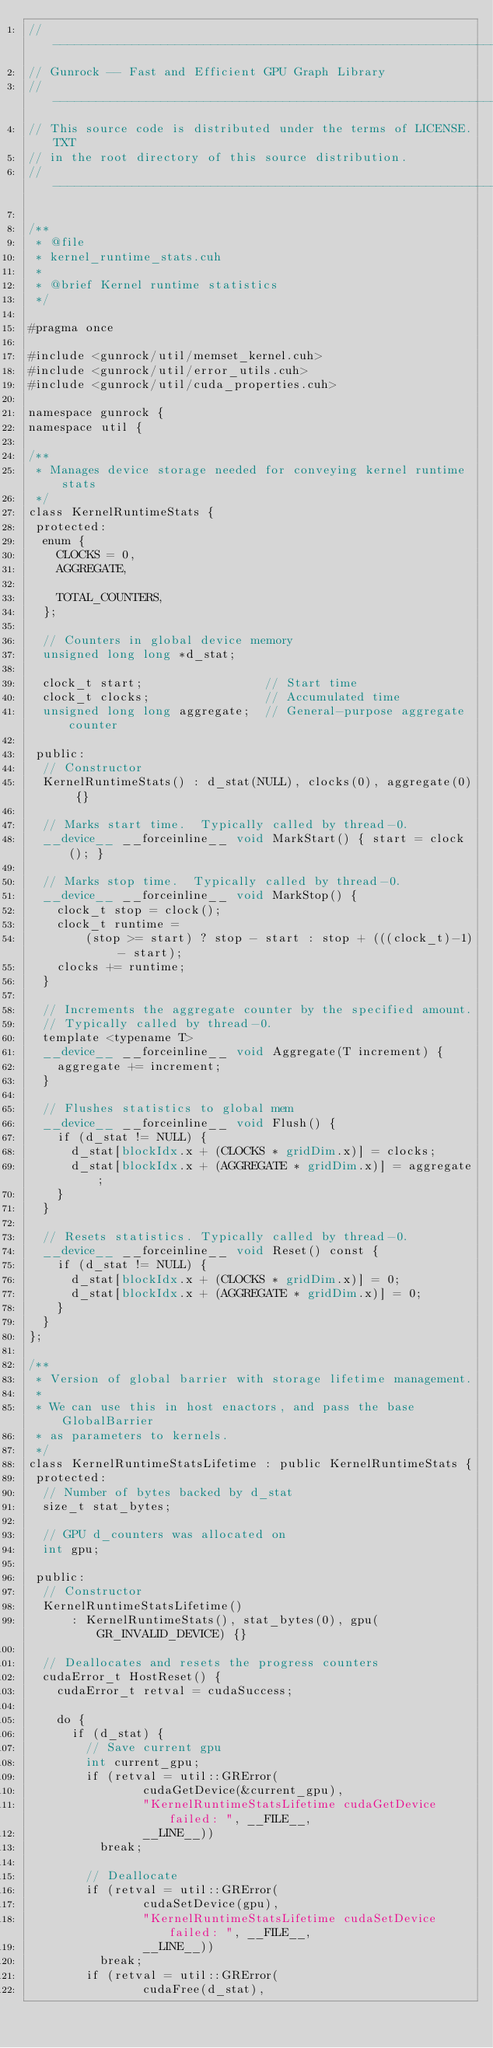Convert code to text. <code><loc_0><loc_0><loc_500><loc_500><_Cuda_>// ----------------------------------------------------------------
// Gunrock -- Fast and Efficient GPU Graph Library
// ----------------------------------------------------------------
// This source code is distributed under the terms of LICENSE.TXT
// in the root directory of this source distribution.
// ----------------------------------------------------------------

/**
 * @file
 * kernel_runtime_stats.cuh
 *
 * @brief Kernel runtime statistics
 */

#pragma once

#include <gunrock/util/memset_kernel.cuh>
#include <gunrock/util/error_utils.cuh>
#include <gunrock/util/cuda_properties.cuh>

namespace gunrock {
namespace util {

/**
 * Manages device storage needed for conveying kernel runtime stats
 */
class KernelRuntimeStats {
 protected:
  enum {
    CLOCKS = 0,
    AGGREGATE,

    TOTAL_COUNTERS,
  };

  // Counters in global device memory
  unsigned long long *d_stat;

  clock_t start;                 // Start time
  clock_t clocks;                // Accumulated time
  unsigned long long aggregate;  // General-purpose aggregate counter

 public:
  // Constructor
  KernelRuntimeStats() : d_stat(NULL), clocks(0), aggregate(0) {}

  // Marks start time.  Typically called by thread-0.
  __device__ __forceinline__ void MarkStart() { start = clock(); }

  // Marks stop time.  Typically called by thread-0.
  __device__ __forceinline__ void MarkStop() {
    clock_t stop = clock();
    clock_t runtime =
        (stop >= start) ? stop - start : stop + (((clock_t)-1) - start);
    clocks += runtime;
  }

  // Increments the aggregate counter by the specified amount.
  // Typically called by thread-0.
  template <typename T>
  __device__ __forceinline__ void Aggregate(T increment) {
    aggregate += increment;
  }

  // Flushes statistics to global mem
  __device__ __forceinline__ void Flush() {
    if (d_stat != NULL) {
      d_stat[blockIdx.x + (CLOCKS * gridDim.x)] = clocks;
      d_stat[blockIdx.x + (AGGREGATE * gridDim.x)] = aggregate;
    }
  }

  // Resets statistics. Typically called by thread-0.
  __device__ __forceinline__ void Reset() const {
    if (d_stat != NULL) {
      d_stat[blockIdx.x + (CLOCKS * gridDim.x)] = 0;
      d_stat[blockIdx.x + (AGGREGATE * gridDim.x)] = 0;
    }
  }
};

/**
 * Version of global barrier with storage lifetime management.
 *
 * We can use this in host enactors, and pass the base GlobalBarrier
 * as parameters to kernels.
 */
class KernelRuntimeStatsLifetime : public KernelRuntimeStats {
 protected:
  // Number of bytes backed by d_stat
  size_t stat_bytes;

  // GPU d_counters was allocated on
  int gpu;

 public:
  // Constructor
  KernelRuntimeStatsLifetime()
      : KernelRuntimeStats(), stat_bytes(0), gpu(GR_INVALID_DEVICE) {}

  // Deallocates and resets the progress counters
  cudaError_t HostReset() {
    cudaError_t retval = cudaSuccess;

    do {
      if (d_stat) {
        // Save current gpu
        int current_gpu;
        if (retval = util::GRError(
                cudaGetDevice(&current_gpu),
                "KernelRuntimeStatsLifetime cudaGetDevice failed: ", __FILE__,
                __LINE__))
          break;

        // Deallocate
        if (retval = util::GRError(
                cudaSetDevice(gpu),
                "KernelRuntimeStatsLifetime cudaSetDevice failed: ", __FILE__,
                __LINE__))
          break;
        if (retval = util::GRError(
                cudaFree(d_stat),</code> 